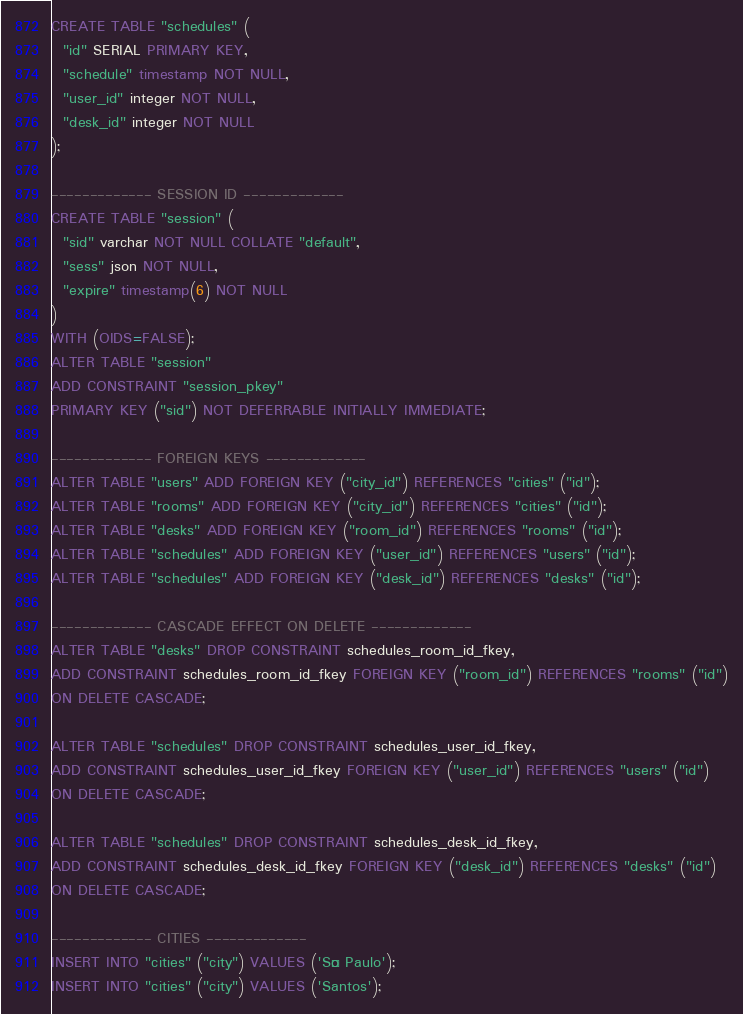Convert code to text. <code><loc_0><loc_0><loc_500><loc_500><_SQL_>
CREATE TABLE "schedules" (
  "id" SERIAL PRIMARY KEY,
  "schedule" timestamp NOT NULL,
  "user_id" integer NOT NULL,
  "desk_id" integer NOT NULL
);

------------- SESSION ID -------------
CREATE TABLE "session" (
  "sid" varchar NOT NULL COLLATE "default",
  "sess" json NOT NULL,
  "expire" timestamp(6) NOT NULL
)
WITH (OIDS=FALSE);
ALTER TABLE "session" 
ADD CONSTRAINT "session_pkey" 
PRIMARY KEY ("sid") NOT DEFERRABLE INITIALLY IMMEDIATE;

------------- FOREIGN KEYS -------------
ALTER TABLE "users" ADD FOREIGN KEY ("city_id") REFERENCES "cities" ("id");
ALTER TABLE "rooms" ADD FOREIGN KEY ("city_id") REFERENCES "cities" ("id");
ALTER TABLE "desks" ADD FOREIGN KEY ("room_id") REFERENCES "rooms" ("id");
ALTER TABLE "schedules" ADD FOREIGN KEY ("user_id") REFERENCES "users" ("id");
ALTER TABLE "schedules" ADD FOREIGN KEY ("desk_id") REFERENCES "desks" ("id");

------------- CASCADE EFFECT ON DELETE -------------
ALTER TABLE "desks" DROP CONSTRAINT schedules_room_id_fkey, 
ADD CONSTRAINT schedules_room_id_fkey FOREIGN KEY ("room_id") REFERENCES "rooms" ("id")
ON DELETE CASCADE;

ALTER TABLE "schedules" DROP CONSTRAINT schedules_user_id_fkey, 
ADD CONSTRAINT schedules_user_id_fkey FOREIGN KEY ("user_id") REFERENCES "users" ("id")
ON DELETE CASCADE;

ALTER TABLE "schedules" DROP CONSTRAINT schedules_desk_id_fkey, 
ADD CONSTRAINT schedules_desk_id_fkey FOREIGN KEY ("desk_id") REFERENCES "desks" ("id")
ON DELETE CASCADE;

------------- CITIES -------------
INSERT INTO "cities" ("city") VALUES ('São Paulo');
INSERT INTO "cities" ("city") VALUES ('Santos');
</code> 